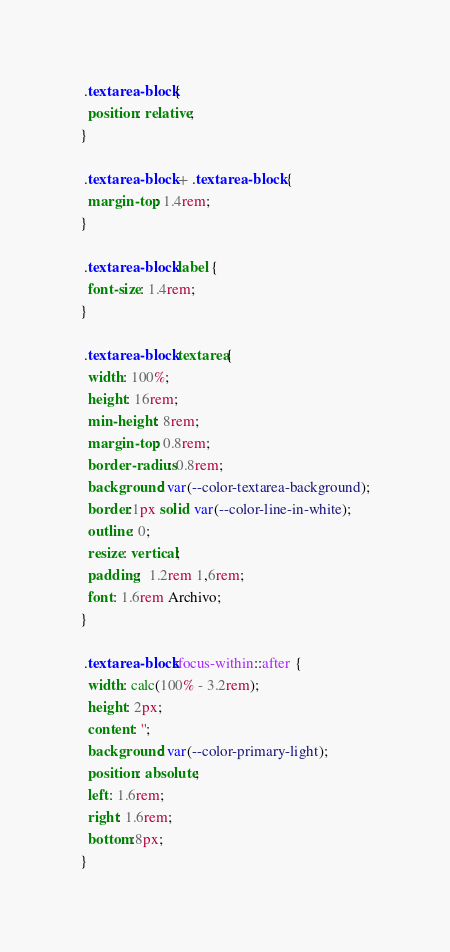Convert code to text. <code><loc_0><loc_0><loc_500><loc_500><_CSS_> .textarea-block{
  position: relative;
}

 .textarea-block + .textarea-block {
  margin-top: 1.4rem;
}

 .textarea-block label {
  font-size: 1.4rem;  
}

 .textarea-block textarea{
  width: 100%;
  height: 16rem;
  min-height: 8rem;
  margin-top: 0.8rem;
  border-radius: 0.8rem;
  background: var(--color-textarea-background);
  border:1px solid var(--color-line-in-white);
  outline: 0;
  resize: vertical;
  padding:  1.2rem 1,6rem;
  font: 1.6rem Archivo;
}

 .textarea-block:focus-within::after {
  width: calc(100% - 3.2rem);
  height: 2px;
  content: '';
  background: var(--color-primary-light);
  position: absolute;
  left: 1.6rem;
  right: 1.6rem;
  bottom:8px;
}
</code> 